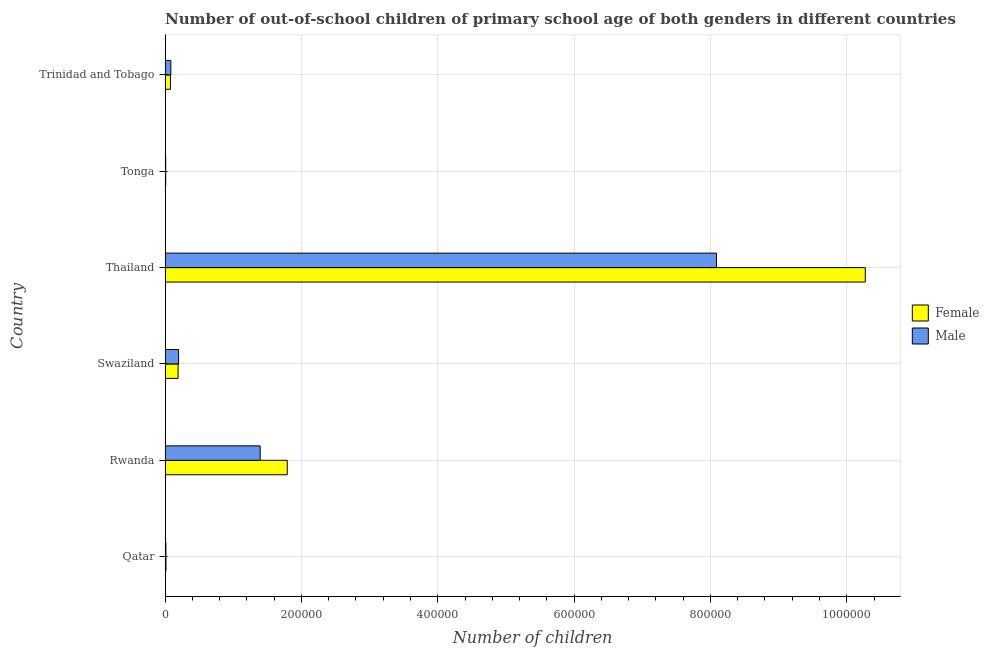How many different coloured bars are there?
Ensure brevity in your answer.  2. Are the number of bars per tick equal to the number of legend labels?
Keep it short and to the point. Yes. What is the label of the 3rd group of bars from the top?
Keep it short and to the point. Thailand. In how many cases, is the number of bars for a given country not equal to the number of legend labels?
Keep it short and to the point. 0. What is the number of male out-of-school students in Trinidad and Tobago?
Your answer should be very brief. 8422. Across all countries, what is the maximum number of male out-of-school students?
Offer a terse response. 8.09e+05. Across all countries, what is the minimum number of male out-of-school students?
Ensure brevity in your answer.  901. In which country was the number of male out-of-school students maximum?
Ensure brevity in your answer.  Thailand. In which country was the number of male out-of-school students minimum?
Your answer should be very brief. Tonga. What is the total number of female out-of-school students in the graph?
Give a very brief answer. 1.24e+06. What is the difference between the number of male out-of-school students in Swaziland and that in Thailand?
Your answer should be very brief. -7.89e+05. What is the difference between the number of male out-of-school students in Trinidad and Tobago and the number of female out-of-school students in Tonga?
Offer a terse response. 7522. What is the average number of female out-of-school students per country?
Provide a short and direct response. 2.06e+05. What is the difference between the number of male out-of-school students and number of female out-of-school students in Trinidad and Tobago?
Keep it short and to the point. 567. What is the ratio of the number of male out-of-school students in Rwanda to that in Trinidad and Tobago?
Offer a terse response. 16.56. What is the difference between the highest and the second highest number of female out-of-school students?
Your response must be concise. 8.48e+05. What is the difference between the highest and the lowest number of female out-of-school students?
Offer a terse response. 1.03e+06. Is the sum of the number of male out-of-school students in Qatar and Tonga greater than the maximum number of female out-of-school students across all countries?
Give a very brief answer. No. What does the 2nd bar from the top in Qatar represents?
Provide a short and direct response. Female. What does the 1st bar from the bottom in Qatar represents?
Offer a terse response. Female. How many bars are there?
Provide a short and direct response. 12. Does the graph contain any zero values?
Offer a very short reply. No. Does the graph contain grids?
Your answer should be very brief. Yes. How many legend labels are there?
Provide a succinct answer. 2. How are the legend labels stacked?
Offer a very short reply. Vertical. What is the title of the graph?
Your answer should be compact. Number of out-of-school children of primary school age of both genders in different countries. Does "Long-term debt" appear as one of the legend labels in the graph?
Provide a succinct answer. No. What is the label or title of the X-axis?
Ensure brevity in your answer.  Number of children. What is the label or title of the Y-axis?
Your response must be concise. Country. What is the Number of children in Female in Qatar?
Provide a short and direct response. 1272. What is the Number of children in Male in Qatar?
Your answer should be compact. 1190. What is the Number of children in Female in Rwanda?
Make the answer very short. 1.79e+05. What is the Number of children of Male in Rwanda?
Make the answer very short. 1.39e+05. What is the Number of children in Female in Swaziland?
Keep it short and to the point. 1.91e+04. What is the Number of children in Male in Swaziland?
Your answer should be compact. 1.97e+04. What is the Number of children of Female in Thailand?
Keep it short and to the point. 1.03e+06. What is the Number of children of Male in Thailand?
Your answer should be very brief. 8.09e+05. What is the Number of children of Female in Tonga?
Your answer should be compact. 900. What is the Number of children of Male in Tonga?
Provide a short and direct response. 901. What is the Number of children of Female in Trinidad and Tobago?
Keep it short and to the point. 7855. What is the Number of children in Male in Trinidad and Tobago?
Offer a terse response. 8422. Across all countries, what is the maximum Number of children of Female?
Your answer should be compact. 1.03e+06. Across all countries, what is the maximum Number of children in Male?
Provide a succinct answer. 8.09e+05. Across all countries, what is the minimum Number of children in Female?
Ensure brevity in your answer.  900. Across all countries, what is the minimum Number of children in Male?
Keep it short and to the point. 901. What is the total Number of children in Female in the graph?
Make the answer very short. 1.24e+06. What is the total Number of children in Male in the graph?
Ensure brevity in your answer.  9.79e+05. What is the difference between the Number of children in Female in Qatar and that in Rwanda?
Give a very brief answer. -1.78e+05. What is the difference between the Number of children in Male in Qatar and that in Rwanda?
Give a very brief answer. -1.38e+05. What is the difference between the Number of children in Female in Qatar and that in Swaziland?
Provide a short and direct response. -1.78e+04. What is the difference between the Number of children in Male in Qatar and that in Swaziland?
Make the answer very short. -1.85e+04. What is the difference between the Number of children in Female in Qatar and that in Thailand?
Make the answer very short. -1.03e+06. What is the difference between the Number of children in Male in Qatar and that in Thailand?
Ensure brevity in your answer.  -8.08e+05. What is the difference between the Number of children in Female in Qatar and that in Tonga?
Offer a terse response. 372. What is the difference between the Number of children in Male in Qatar and that in Tonga?
Keep it short and to the point. 289. What is the difference between the Number of children of Female in Qatar and that in Trinidad and Tobago?
Your answer should be compact. -6583. What is the difference between the Number of children in Male in Qatar and that in Trinidad and Tobago?
Your response must be concise. -7232. What is the difference between the Number of children in Female in Rwanda and that in Swaziland?
Your answer should be very brief. 1.60e+05. What is the difference between the Number of children of Male in Rwanda and that in Swaziland?
Ensure brevity in your answer.  1.20e+05. What is the difference between the Number of children of Female in Rwanda and that in Thailand?
Provide a succinct answer. -8.48e+05. What is the difference between the Number of children in Male in Rwanda and that in Thailand?
Offer a very short reply. -6.69e+05. What is the difference between the Number of children of Female in Rwanda and that in Tonga?
Your response must be concise. 1.78e+05. What is the difference between the Number of children of Male in Rwanda and that in Tonga?
Provide a succinct answer. 1.39e+05. What is the difference between the Number of children in Female in Rwanda and that in Trinidad and Tobago?
Ensure brevity in your answer.  1.71e+05. What is the difference between the Number of children of Male in Rwanda and that in Trinidad and Tobago?
Make the answer very short. 1.31e+05. What is the difference between the Number of children in Female in Swaziland and that in Thailand?
Make the answer very short. -1.01e+06. What is the difference between the Number of children in Male in Swaziland and that in Thailand?
Your response must be concise. -7.89e+05. What is the difference between the Number of children of Female in Swaziland and that in Tonga?
Keep it short and to the point. 1.82e+04. What is the difference between the Number of children of Male in Swaziland and that in Tonga?
Keep it short and to the point. 1.88e+04. What is the difference between the Number of children of Female in Swaziland and that in Trinidad and Tobago?
Provide a succinct answer. 1.12e+04. What is the difference between the Number of children in Male in Swaziland and that in Trinidad and Tobago?
Your response must be concise. 1.13e+04. What is the difference between the Number of children of Female in Thailand and that in Tonga?
Your response must be concise. 1.03e+06. What is the difference between the Number of children of Male in Thailand and that in Tonga?
Your answer should be very brief. 8.08e+05. What is the difference between the Number of children in Female in Thailand and that in Trinidad and Tobago?
Ensure brevity in your answer.  1.02e+06. What is the difference between the Number of children of Male in Thailand and that in Trinidad and Tobago?
Your answer should be compact. 8.00e+05. What is the difference between the Number of children in Female in Tonga and that in Trinidad and Tobago?
Your answer should be very brief. -6955. What is the difference between the Number of children in Male in Tonga and that in Trinidad and Tobago?
Your response must be concise. -7521. What is the difference between the Number of children in Female in Qatar and the Number of children in Male in Rwanda?
Your answer should be very brief. -1.38e+05. What is the difference between the Number of children in Female in Qatar and the Number of children in Male in Swaziland?
Provide a succinct answer. -1.85e+04. What is the difference between the Number of children of Female in Qatar and the Number of children of Male in Thailand?
Your answer should be compact. -8.08e+05. What is the difference between the Number of children of Female in Qatar and the Number of children of Male in Tonga?
Offer a very short reply. 371. What is the difference between the Number of children in Female in Qatar and the Number of children in Male in Trinidad and Tobago?
Ensure brevity in your answer.  -7150. What is the difference between the Number of children in Female in Rwanda and the Number of children in Male in Swaziland?
Your response must be concise. 1.59e+05. What is the difference between the Number of children in Female in Rwanda and the Number of children in Male in Thailand?
Offer a very short reply. -6.30e+05. What is the difference between the Number of children of Female in Rwanda and the Number of children of Male in Tonga?
Make the answer very short. 1.78e+05. What is the difference between the Number of children of Female in Rwanda and the Number of children of Male in Trinidad and Tobago?
Provide a short and direct response. 1.71e+05. What is the difference between the Number of children of Female in Swaziland and the Number of children of Male in Thailand?
Your answer should be compact. -7.90e+05. What is the difference between the Number of children of Female in Swaziland and the Number of children of Male in Tonga?
Your response must be concise. 1.82e+04. What is the difference between the Number of children of Female in Swaziland and the Number of children of Male in Trinidad and Tobago?
Make the answer very short. 1.06e+04. What is the difference between the Number of children of Female in Thailand and the Number of children of Male in Tonga?
Keep it short and to the point. 1.03e+06. What is the difference between the Number of children of Female in Thailand and the Number of children of Male in Trinidad and Tobago?
Offer a very short reply. 1.02e+06. What is the difference between the Number of children in Female in Tonga and the Number of children in Male in Trinidad and Tobago?
Your answer should be compact. -7522. What is the average Number of children in Female per country?
Your answer should be very brief. 2.06e+05. What is the average Number of children in Male per country?
Your answer should be very brief. 1.63e+05. What is the difference between the Number of children of Female and Number of children of Male in Qatar?
Your answer should be compact. 82. What is the difference between the Number of children of Female and Number of children of Male in Rwanda?
Provide a short and direct response. 3.97e+04. What is the difference between the Number of children in Female and Number of children in Male in Swaziland?
Give a very brief answer. -667. What is the difference between the Number of children in Female and Number of children in Male in Thailand?
Make the answer very short. 2.18e+05. What is the difference between the Number of children of Female and Number of children of Male in Tonga?
Make the answer very short. -1. What is the difference between the Number of children in Female and Number of children in Male in Trinidad and Tobago?
Your answer should be very brief. -567. What is the ratio of the Number of children in Female in Qatar to that in Rwanda?
Make the answer very short. 0.01. What is the ratio of the Number of children in Male in Qatar to that in Rwanda?
Your answer should be very brief. 0.01. What is the ratio of the Number of children of Female in Qatar to that in Swaziland?
Your answer should be very brief. 0.07. What is the ratio of the Number of children in Male in Qatar to that in Swaziland?
Make the answer very short. 0.06. What is the ratio of the Number of children of Female in Qatar to that in Thailand?
Offer a terse response. 0. What is the ratio of the Number of children of Male in Qatar to that in Thailand?
Offer a terse response. 0. What is the ratio of the Number of children in Female in Qatar to that in Tonga?
Your answer should be very brief. 1.41. What is the ratio of the Number of children of Male in Qatar to that in Tonga?
Offer a terse response. 1.32. What is the ratio of the Number of children of Female in Qatar to that in Trinidad and Tobago?
Your answer should be compact. 0.16. What is the ratio of the Number of children in Male in Qatar to that in Trinidad and Tobago?
Offer a terse response. 0.14. What is the ratio of the Number of children in Female in Rwanda to that in Swaziland?
Give a very brief answer. 9.4. What is the ratio of the Number of children in Male in Rwanda to that in Swaziland?
Provide a short and direct response. 7.07. What is the ratio of the Number of children of Female in Rwanda to that in Thailand?
Your answer should be very brief. 0.17. What is the ratio of the Number of children of Male in Rwanda to that in Thailand?
Keep it short and to the point. 0.17. What is the ratio of the Number of children in Female in Rwanda to that in Tonga?
Provide a short and direct response. 199.12. What is the ratio of the Number of children of Male in Rwanda to that in Tonga?
Your answer should be very brief. 154.79. What is the ratio of the Number of children of Female in Rwanda to that in Trinidad and Tobago?
Offer a very short reply. 22.81. What is the ratio of the Number of children in Male in Rwanda to that in Trinidad and Tobago?
Make the answer very short. 16.56. What is the ratio of the Number of children in Female in Swaziland to that in Thailand?
Give a very brief answer. 0.02. What is the ratio of the Number of children of Male in Swaziland to that in Thailand?
Offer a terse response. 0.02. What is the ratio of the Number of children in Female in Swaziland to that in Tonga?
Offer a terse response. 21.19. What is the ratio of the Number of children of Male in Swaziland to that in Tonga?
Keep it short and to the point. 21.9. What is the ratio of the Number of children in Female in Swaziland to that in Trinidad and Tobago?
Provide a succinct answer. 2.43. What is the ratio of the Number of children in Male in Swaziland to that in Trinidad and Tobago?
Keep it short and to the point. 2.34. What is the ratio of the Number of children of Female in Thailand to that in Tonga?
Ensure brevity in your answer.  1141.28. What is the ratio of the Number of children of Male in Thailand to that in Tonga?
Provide a succinct answer. 897.76. What is the ratio of the Number of children of Female in Thailand to that in Trinidad and Tobago?
Make the answer very short. 130.76. What is the ratio of the Number of children of Male in Thailand to that in Trinidad and Tobago?
Your answer should be very brief. 96.04. What is the ratio of the Number of children in Female in Tonga to that in Trinidad and Tobago?
Provide a succinct answer. 0.11. What is the ratio of the Number of children of Male in Tonga to that in Trinidad and Tobago?
Provide a succinct answer. 0.11. What is the difference between the highest and the second highest Number of children of Female?
Your response must be concise. 8.48e+05. What is the difference between the highest and the second highest Number of children in Male?
Keep it short and to the point. 6.69e+05. What is the difference between the highest and the lowest Number of children of Female?
Give a very brief answer. 1.03e+06. What is the difference between the highest and the lowest Number of children in Male?
Offer a very short reply. 8.08e+05. 